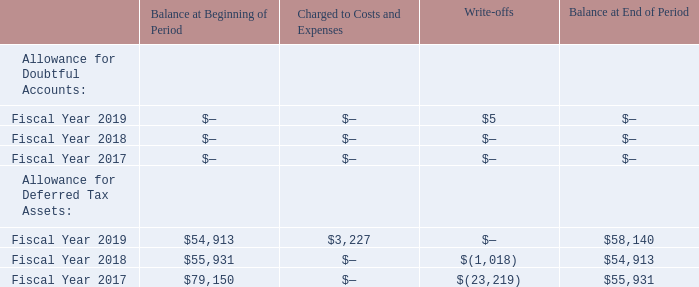ITEM 15. EXHIBITS AND FINANCIAL STATEMENT SCHEDULES
(a) 1. Financial Statements
Reference is made to Item 8 for a list of all financial statements and schedules filed as a part of this Report.
2. Financial Statement Schedules
QuickLogic Corporation
Valuation and Qualifying Accounts
(in thousands)
All other schedules not listed above have been omitted because the information required to be set forth therein is not applicable or is shown in the financial statements or notes hereto.
What are the respective balance at the beginning of the period for fiscal year 2018 and 2019?
Answer scale should be: thousand. $55,931, $54,913. What are the respective balance at the end of the period for fiscal year 2018 and 2019?
Answer scale should be: thousand. $54,913, $58,140. What is the amount charged to costs and expenses in fiscal year 2019?
Answer scale should be: thousand. $3,227. What is the total balance at the beginning of the period in fiscal year 2018 and 2019?
Answer scale should be: thousand. $55,931 + $54,913 
Answer: 110844. What is the average at the beginning of the period in fiscal year 2018 and 2019?
Answer scale should be: thousand. ($55,931 + $54,913)/2 
Answer: 55422. What is the value of the balance at the beginning of 2019 as a percentage of the balance at the end of 2019?
Answer scale should be: percent. $54,913/$58,140 
Answer: 94.45. 